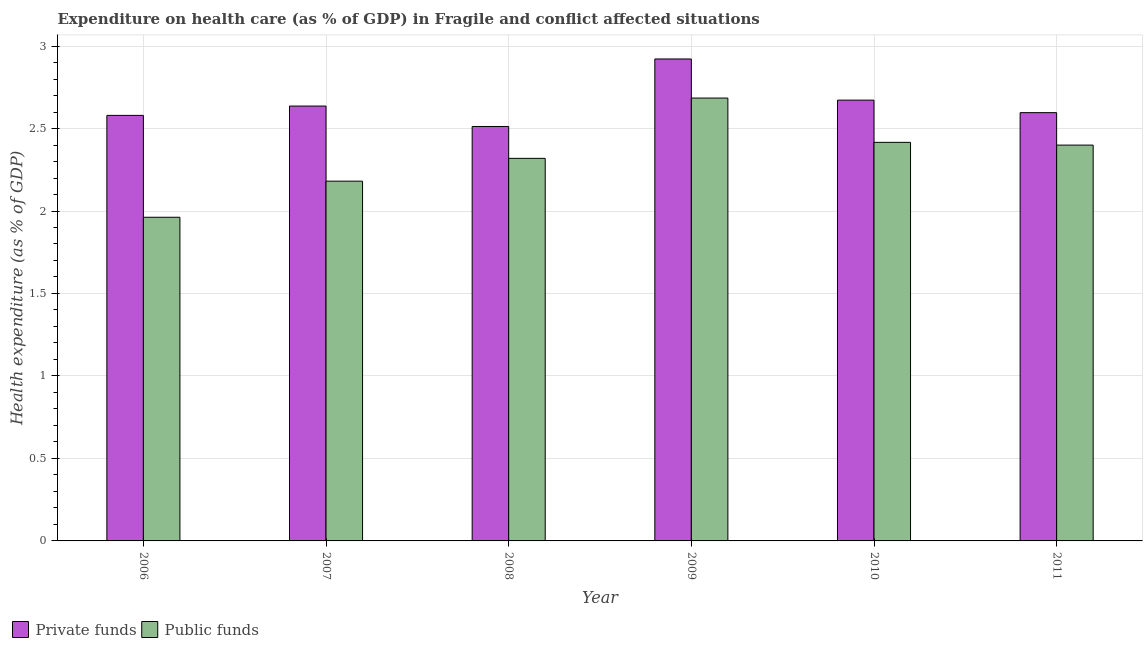How many different coloured bars are there?
Your answer should be compact. 2. How many groups of bars are there?
Offer a very short reply. 6. Are the number of bars on each tick of the X-axis equal?
Your answer should be compact. Yes. How many bars are there on the 3rd tick from the left?
Offer a terse response. 2. How many bars are there on the 4th tick from the right?
Offer a very short reply. 2. What is the label of the 1st group of bars from the left?
Ensure brevity in your answer.  2006. In how many cases, is the number of bars for a given year not equal to the number of legend labels?
Give a very brief answer. 0. What is the amount of private funds spent in healthcare in 2010?
Offer a very short reply. 2.67. Across all years, what is the maximum amount of public funds spent in healthcare?
Ensure brevity in your answer.  2.68. Across all years, what is the minimum amount of private funds spent in healthcare?
Your answer should be very brief. 2.51. In which year was the amount of public funds spent in healthcare maximum?
Provide a short and direct response. 2009. In which year was the amount of public funds spent in healthcare minimum?
Provide a succinct answer. 2006. What is the total amount of private funds spent in healthcare in the graph?
Your answer should be very brief. 15.92. What is the difference between the amount of private funds spent in healthcare in 2006 and that in 2011?
Your response must be concise. -0.02. What is the difference between the amount of public funds spent in healthcare in 2006 and the amount of private funds spent in healthcare in 2007?
Give a very brief answer. -0.22. What is the average amount of private funds spent in healthcare per year?
Keep it short and to the point. 2.65. What is the ratio of the amount of private funds spent in healthcare in 2007 to that in 2010?
Keep it short and to the point. 0.99. Is the difference between the amount of public funds spent in healthcare in 2007 and 2010 greater than the difference between the amount of private funds spent in healthcare in 2007 and 2010?
Provide a short and direct response. No. What is the difference between the highest and the second highest amount of private funds spent in healthcare?
Offer a very short reply. 0.25. What is the difference between the highest and the lowest amount of public funds spent in healthcare?
Your answer should be very brief. 0.72. What does the 2nd bar from the left in 2008 represents?
Provide a short and direct response. Public funds. What does the 2nd bar from the right in 2011 represents?
Ensure brevity in your answer.  Private funds. Are all the bars in the graph horizontal?
Ensure brevity in your answer.  No. How many years are there in the graph?
Your answer should be compact. 6. Does the graph contain grids?
Provide a succinct answer. Yes. Where does the legend appear in the graph?
Make the answer very short. Bottom left. How many legend labels are there?
Give a very brief answer. 2. How are the legend labels stacked?
Provide a short and direct response. Horizontal. What is the title of the graph?
Ensure brevity in your answer.  Expenditure on health care (as % of GDP) in Fragile and conflict affected situations. What is the label or title of the X-axis?
Make the answer very short. Year. What is the label or title of the Y-axis?
Provide a succinct answer. Health expenditure (as % of GDP). What is the Health expenditure (as % of GDP) of Private funds in 2006?
Ensure brevity in your answer.  2.58. What is the Health expenditure (as % of GDP) of Public funds in 2006?
Give a very brief answer. 1.96. What is the Health expenditure (as % of GDP) of Private funds in 2007?
Keep it short and to the point. 2.64. What is the Health expenditure (as % of GDP) of Public funds in 2007?
Offer a terse response. 2.18. What is the Health expenditure (as % of GDP) of Private funds in 2008?
Your answer should be very brief. 2.51. What is the Health expenditure (as % of GDP) of Public funds in 2008?
Offer a very short reply. 2.32. What is the Health expenditure (as % of GDP) in Private funds in 2009?
Your answer should be compact. 2.92. What is the Health expenditure (as % of GDP) of Public funds in 2009?
Keep it short and to the point. 2.68. What is the Health expenditure (as % of GDP) of Private funds in 2010?
Offer a terse response. 2.67. What is the Health expenditure (as % of GDP) of Public funds in 2010?
Ensure brevity in your answer.  2.42. What is the Health expenditure (as % of GDP) of Private funds in 2011?
Your response must be concise. 2.6. What is the Health expenditure (as % of GDP) in Public funds in 2011?
Your answer should be compact. 2.4. Across all years, what is the maximum Health expenditure (as % of GDP) in Private funds?
Your response must be concise. 2.92. Across all years, what is the maximum Health expenditure (as % of GDP) of Public funds?
Provide a succinct answer. 2.68. Across all years, what is the minimum Health expenditure (as % of GDP) of Private funds?
Provide a succinct answer. 2.51. Across all years, what is the minimum Health expenditure (as % of GDP) in Public funds?
Offer a very short reply. 1.96. What is the total Health expenditure (as % of GDP) of Private funds in the graph?
Your answer should be very brief. 15.92. What is the total Health expenditure (as % of GDP) of Public funds in the graph?
Give a very brief answer. 13.96. What is the difference between the Health expenditure (as % of GDP) in Private funds in 2006 and that in 2007?
Offer a terse response. -0.06. What is the difference between the Health expenditure (as % of GDP) of Public funds in 2006 and that in 2007?
Offer a very short reply. -0.22. What is the difference between the Health expenditure (as % of GDP) in Private funds in 2006 and that in 2008?
Make the answer very short. 0.07. What is the difference between the Health expenditure (as % of GDP) in Public funds in 2006 and that in 2008?
Ensure brevity in your answer.  -0.36. What is the difference between the Health expenditure (as % of GDP) in Private funds in 2006 and that in 2009?
Your answer should be compact. -0.34. What is the difference between the Health expenditure (as % of GDP) in Public funds in 2006 and that in 2009?
Give a very brief answer. -0.72. What is the difference between the Health expenditure (as % of GDP) in Private funds in 2006 and that in 2010?
Your answer should be very brief. -0.09. What is the difference between the Health expenditure (as % of GDP) in Public funds in 2006 and that in 2010?
Give a very brief answer. -0.45. What is the difference between the Health expenditure (as % of GDP) of Private funds in 2006 and that in 2011?
Ensure brevity in your answer.  -0.02. What is the difference between the Health expenditure (as % of GDP) in Public funds in 2006 and that in 2011?
Ensure brevity in your answer.  -0.44. What is the difference between the Health expenditure (as % of GDP) of Private funds in 2007 and that in 2008?
Give a very brief answer. 0.12. What is the difference between the Health expenditure (as % of GDP) in Public funds in 2007 and that in 2008?
Provide a succinct answer. -0.14. What is the difference between the Health expenditure (as % of GDP) of Private funds in 2007 and that in 2009?
Ensure brevity in your answer.  -0.29. What is the difference between the Health expenditure (as % of GDP) of Public funds in 2007 and that in 2009?
Your response must be concise. -0.5. What is the difference between the Health expenditure (as % of GDP) of Private funds in 2007 and that in 2010?
Give a very brief answer. -0.04. What is the difference between the Health expenditure (as % of GDP) of Public funds in 2007 and that in 2010?
Your answer should be compact. -0.24. What is the difference between the Health expenditure (as % of GDP) in Private funds in 2007 and that in 2011?
Make the answer very short. 0.04. What is the difference between the Health expenditure (as % of GDP) of Public funds in 2007 and that in 2011?
Offer a terse response. -0.22. What is the difference between the Health expenditure (as % of GDP) in Private funds in 2008 and that in 2009?
Keep it short and to the point. -0.41. What is the difference between the Health expenditure (as % of GDP) of Public funds in 2008 and that in 2009?
Your answer should be compact. -0.37. What is the difference between the Health expenditure (as % of GDP) of Private funds in 2008 and that in 2010?
Your answer should be compact. -0.16. What is the difference between the Health expenditure (as % of GDP) in Public funds in 2008 and that in 2010?
Ensure brevity in your answer.  -0.1. What is the difference between the Health expenditure (as % of GDP) in Private funds in 2008 and that in 2011?
Ensure brevity in your answer.  -0.08. What is the difference between the Health expenditure (as % of GDP) in Public funds in 2008 and that in 2011?
Keep it short and to the point. -0.08. What is the difference between the Health expenditure (as % of GDP) in Private funds in 2009 and that in 2010?
Your answer should be very brief. 0.25. What is the difference between the Health expenditure (as % of GDP) in Public funds in 2009 and that in 2010?
Offer a terse response. 0.27. What is the difference between the Health expenditure (as % of GDP) of Private funds in 2009 and that in 2011?
Offer a very short reply. 0.33. What is the difference between the Health expenditure (as % of GDP) of Public funds in 2009 and that in 2011?
Offer a very short reply. 0.29. What is the difference between the Health expenditure (as % of GDP) of Private funds in 2010 and that in 2011?
Provide a short and direct response. 0.08. What is the difference between the Health expenditure (as % of GDP) in Public funds in 2010 and that in 2011?
Make the answer very short. 0.02. What is the difference between the Health expenditure (as % of GDP) in Private funds in 2006 and the Health expenditure (as % of GDP) in Public funds in 2007?
Provide a succinct answer. 0.4. What is the difference between the Health expenditure (as % of GDP) in Private funds in 2006 and the Health expenditure (as % of GDP) in Public funds in 2008?
Your response must be concise. 0.26. What is the difference between the Health expenditure (as % of GDP) of Private funds in 2006 and the Health expenditure (as % of GDP) of Public funds in 2009?
Give a very brief answer. -0.11. What is the difference between the Health expenditure (as % of GDP) in Private funds in 2006 and the Health expenditure (as % of GDP) in Public funds in 2010?
Provide a short and direct response. 0.16. What is the difference between the Health expenditure (as % of GDP) in Private funds in 2006 and the Health expenditure (as % of GDP) in Public funds in 2011?
Make the answer very short. 0.18. What is the difference between the Health expenditure (as % of GDP) of Private funds in 2007 and the Health expenditure (as % of GDP) of Public funds in 2008?
Your response must be concise. 0.32. What is the difference between the Health expenditure (as % of GDP) in Private funds in 2007 and the Health expenditure (as % of GDP) in Public funds in 2009?
Ensure brevity in your answer.  -0.05. What is the difference between the Health expenditure (as % of GDP) of Private funds in 2007 and the Health expenditure (as % of GDP) of Public funds in 2010?
Provide a succinct answer. 0.22. What is the difference between the Health expenditure (as % of GDP) of Private funds in 2007 and the Health expenditure (as % of GDP) of Public funds in 2011?
Your answer should be compact. 0.24. What is the difference between the Health expenditure (as % of GDP) in Private funds in 2008 and the Health expenditure (as % of GDP) in Public funds in 2009?
Give a very brief answer. -0.17. What is the difference between the Health expenditure (as % of GDP) of Private funds in 2008 and the Health expenditure (as % of GDP) of Public funds in 2010?
Give a very brief answer. 0.1. What is the difference between the Health expenditure (as % of GDP) in Private funds in 2008 and the Health expenditure (as % of GDP) in Public funds in 2011?
Your response must be concise. 0.11. What is the difference between the Health expenditure (as % of GDP) in Private funds in 2009 and the Health expenditure (as % of GDP) in Public funds in 2010?
Keep it short and to the point. 0.51. What is the difference between the Health expenditure (as % of GDP) in Private funds in 2009 and the Health expenditure (as % of GDP) in Public funds in 2011?
Make the answer very short. 0.52. What is the difference between the Health expenditure (as % of GDP) of Private funds in 2010 and the Health expenditure (as % of GDP) of Public funds in 2011?
Provide a succinct answer. 0.27. What is the average Health expenditure (as % of GDP) in Private funds per year?
Make the answer very short. 2.65. What is the average Health expenditure (as % of GDP) in Public funds per year?
Provide a short and direct response. 2.33. In the year 2006, what is the difference between the Health expenditure (as % of GDP) of Private funds and Health expenditure (as % of GDP) of Public funds?
Give a very brief answer. 0.62. In the year 2007, what is the difference between the Health expenditure (as % of GDP) in Private funds and Health expenditure (as % of GDP) in Public funds?
Ensure brevity in your answer.  0.46. In the year 2008, what is the difference between the Health expenditure (as % of GDP) of Private funds and Health expenditure (as % of GDP) of Public funds?
Make the answer very short. 0.19. In the year 2009, what is the difference between the Health expenditure (as % of GDP) in Private funds and Health expenditure (as % of GDP) in Public funds?
Make the answer very short. 0.24. In the year 2010, what is the difference between the Health expenditure (as % of GDP) in Private funds and Health expenditure (as % of GDP) in Public funds?
Provide a short and direct response. 0.26. In the year 2011, what is the difference between the Health expenditure (as % of GDP) in Private funds and Health expenditure (as % of GDP) in Public funds?
Give a very brief answer. 0.2. What is the ratio of the Health expenditure (as % of GDP) in Private funds in 2006 to that in 2007?
Offer a very short reply. 0.98. What is the ratio of the Health expenditure (as % of GDP) of Public funds in 2006 to that in 2007?
Provide a short and direct response. 0.9. What is the ratio of the Health expenditure (as % of GDP) of Private funds in 2006 to that in 2008?
Make the answer very short. 1.03. What is the ratio of the Health expenditure (as % of GDP) of Public funds in 2006 to that in 2008?
Offer a terse response. 0.85. What is the ratio of the Health expenditure (as % of GDP) of Private funds in 2006 to that in 2009?
Your response must be concise. 0.88. What is the ratio of the Health expenditure (as % of GDP) in Public funds in 2006 to that in 2009?
Keep it short and to the point. 0.73. What is the ratio of the Health expenditure (as % of GDP) of Private funds in 2006 to that in 2010?
Give a very brief answer. 0.97. What is the ratio of the Health expenditure (as % of GDP) of Public funds in 2006 to that in 2010?
Your answer should be very brief. 0.81. What is the ratio of the Health expenditure (as % of GDP) in Public funds in 2006 to that in 2011?
Make the answer very short. 0.82. What is the ratio of the Health expenditure (as % of GDP) in Private funds in 2007 to that in 2008?
Make the answer very short. 1.05. What is the ratio of the Health expenditure (as % of GDP) of Public funds in 2007 to that in 2008?
Give a very brief answer. 0.94. What is the ratio of the Health expenditure (as % of GDP) of Private funds in 2007 to that in 2009?
Keep it short and to the point. 0.9. What is the ratio of the Health expenditure (as % of GDP) in Public funds in 2007 to that in 2009?
Give a very brief answer. 0.81. What is the ratio of the Health expenditure (as % of GDP) in Private funds in 2007 to that in 2010?
Give a very brief answer. 0.99. What is the ratio of the Health expenditure (as % of GDP) of Public funds in 2007 to that in 2010?
Make the answer very short. 0.9. What is the ratio of the Health expenditure (as % of GDP) in Private funds in 2007 to that in 2011?
Offer a terse response. 1.02. What is the ratio of the Health expenditure (as % of GDP) of Public funds in 2007 to that in 2011?
Give a very brief answer. 0.91. What is the ratio of the Health expenditure (as % of GDP) of Private funds in 2008 to that in 2009?
Your answer should be very brief. 0.86. What is the ratio of the Health expenditure (as % of GDP) in Public funds in 2008 to that in 2009?
Offer a very short reply. 0.86. What is the ratio of the Health expenditure (as % of GDP) in Private funds in 2008 to that in 2010?
Make the answer very short. 0.94. What is the ratio of the Health expenditure (as % of GDP) of Public funds in 2008 to that in 2010?
Make the answer very short. 0.96. What is the ratio of the Health expenditure (as % of GDP) in Public funds in 2008 to that in 2011?
Keep it short and to the point. 0.97. What is the ratio of the Health expenditure (as % of GDP) in Private funds in 2009 to that in 2010?
Your answer should be compact. 1.09. What is the ratio of the Health expenditure (as % of GDP) of Public funds in 2009 to that in 2010?
Your answer should be compact. 1.11. What is the ratio of the Health expenditure (as % of GDP) in Private funds in 2009 to that in 2011?
Give a very brief answer. 1.13. What is the ratio of the Health expenditure (as % of GDP) in Public funds in 2009 to that in 2011?
Provide a succinct answer. 1.12. What is the ratio of the Health expenditure (as % of GDP) of Private funds in 2010 to that in 2011?
Offer a very short reply. 1.03. What is the ratio of the Health expenditure (as % of GDP) in Public funds in 2010 to that in 2011?
Keep it short and to the point. 1.01. What is the difference between the highest and the second highest Health expenditure (as % of GDP) of Private funds?
Your answer should be very brief. 0.25. What is the difference between the highest and the second highest Health expenditure (as % of GDP) of Public funds?
Your response must be concise. 0.27. What is the difference between the highest and the lowest Health expenditure (as % of GDP) of Private funds?
Keep it short and to the point. 0.41. What is the difference between the highest and the lowest Health expenditure (as % of GDP) of Public funds?
Your answer should be compact. 0.72. 